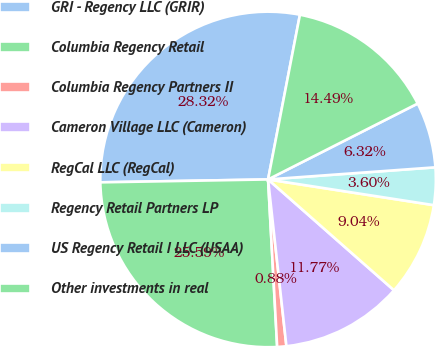Convert chart. <chart><loc_0><loc_0><loc_500><loc_500><pie_chart><fcel>GRI - Regency LLC (GRIR)<fcel>Columbia Regency Retail<fcel>Columbia Regency Partners II<fcel>Cameron Village LLC (Cameron)<fcel>RegCal LLC (RegCal)<fcel>Regency Retail Partners LP<fcel>US Regency Retail I LLC (USAA)<fcel>Other investments in real<nl><fcel>28.32%<fcel>25.59%<fcel>0.88%<fcel>11.77%<fcel>9.04%<fcel>3.6%<fcel>6.32%<fcel>14.49%<nl></chart> 